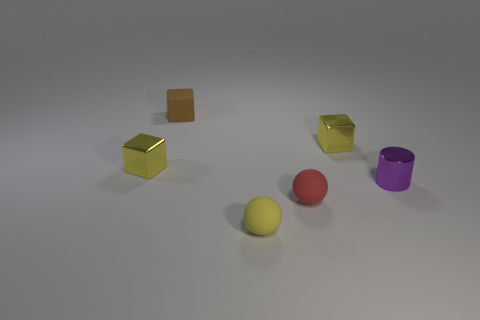Add 2 small brown matte blocks. How many objects exist? 8 Subtract all cylinders. How many objects are left? 5 Add 2 small red balls. How many small red balls exist? 3 Subtract 0 purple cubes. How many objects are left? 6 Subtract all large green metallic cylinders. Subtract all red rubber spheres. How many objects are left? 5 Add 4 small metallic cylinders. How many small metallic cylinders are left? 5 